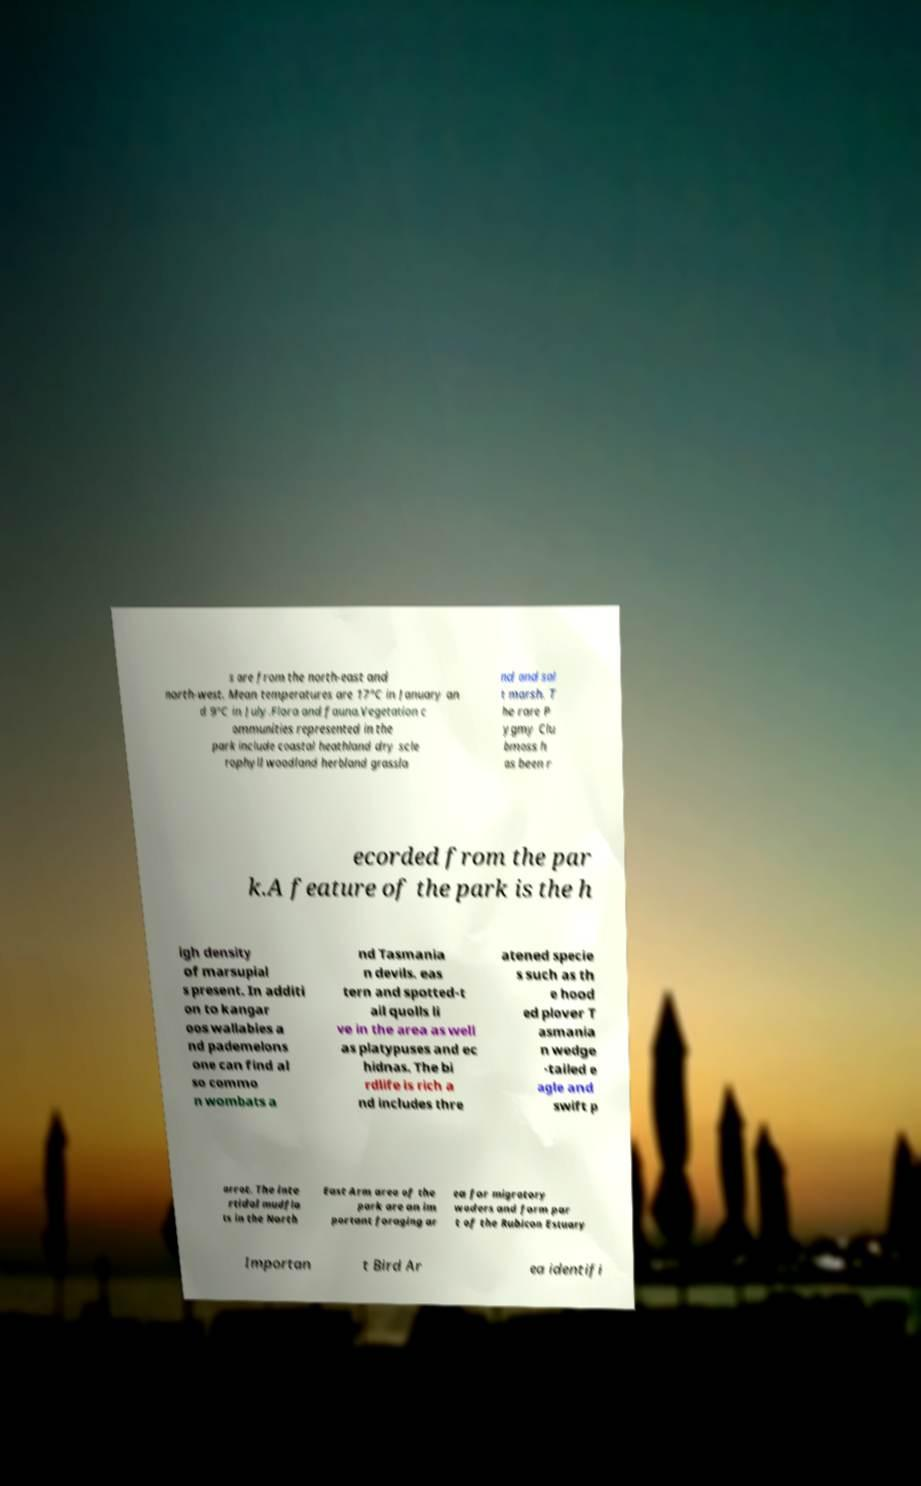What messages or text are displayed in this image? I need them in a readable, typed format. s are from the north-east and north-west. Mean temperatures are 17°C in January an d 9°C in July.Flora and fauna.Vegetation c ommunities represented in the park include coastal heathland dry scle rophyll woodland herbland grassla nd and sal t marsh. T he rare P ygmy Clu bmoss h as been r ecorded from the par k.A feature of the park is the h igh density of marsupial s present. In additi on to kangar oos wallabies a nd pademelons one can find al so commo n wombats a nd Tasmania n devils. eas tern and spotted-t ail quolls li ve in the area as well as platypuses and ec hidnas. The bi rdlife is rich a nd includes thre atened specie s such as th e hood ed plover T asmania n wedge -tailed e agle and swift p arrot. The inte rtidal mudfla ts in the North East Arm area of the park are an im portant foraging ar ea for migratory waders and form par t of the Rubicon Estuary Importan t Bird Ar ea identifi 